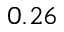<formula> <loc_0><loc_0><loc_500><loc_500>0 . 2 6</formula> 